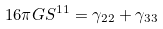Convert formula to latex. <formula><loc_0><loc_0><loc_500><loc_500>1 6 \pi G S ^ { 1 1 } = \gamma _ { 2 2 } + \gamma _ { 3 3 }</formula> 